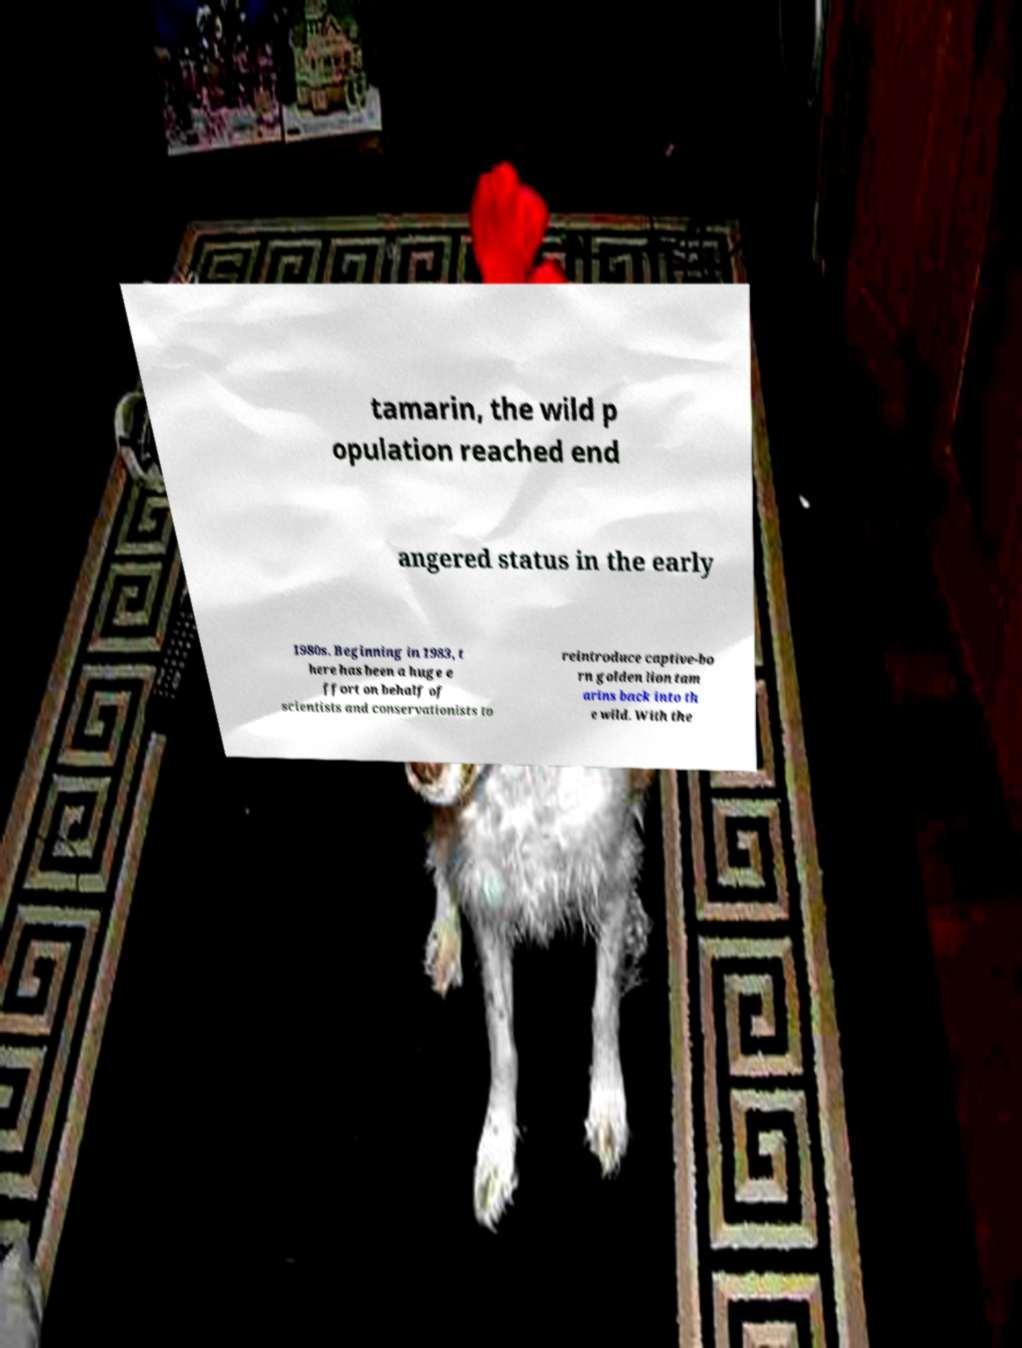What messages or text are displayed in this image? I need them in a readable, typed format. tamarin, the wild p opulation reached end angered status in the early 1980s. Beginning in 1983, t here has been a huge e ffort on behalf of scientists and conservationists to reintroduce captive-bo rn golden lion tam arins back into th e wild. With the 